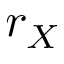<formula> <loc_0><loc_0><loc_500><loc_500>r _ { X }</formula> 